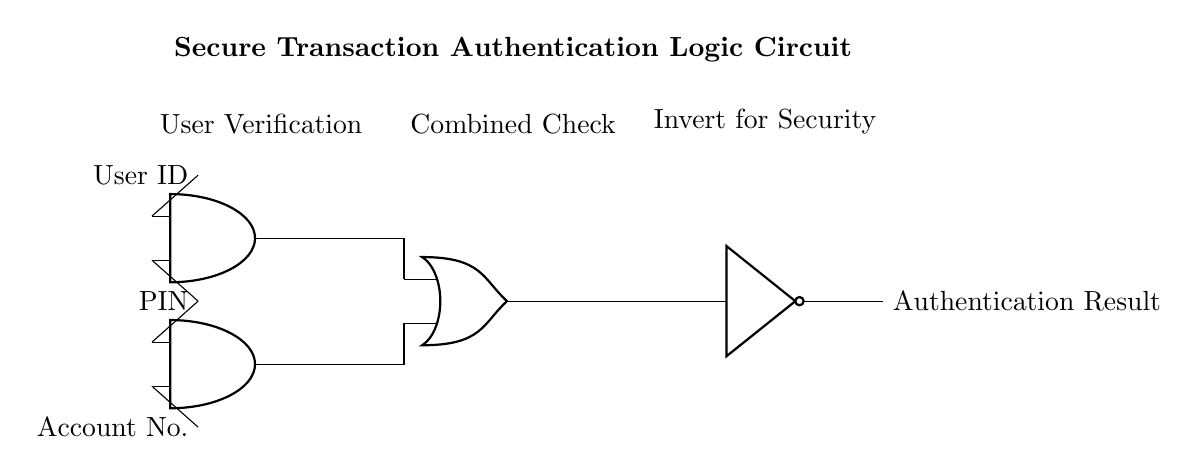What are the main components in this circuit? The circuit contains AND gates, an OR gate, and a NOT gate, which are the basic logic gates used for processing the authentication inputs.
Answer: AND gates, OR gate, NOT gate How many input signals are there in the circuit? There are three input signals: User ID, PIN, and Account Number. Each input contributes to the authentication logic.
Answer: Three What is the output of the circuit? The output is the "Authentication Result," which indicates whether the transaction is secure based on the inputs processed through the logic gates.
Answer: Authentication Result Where do the AND gates receive their inputs from? The first AND gate receives inputs from User ID and PIN, while the second AND gate receives inputs from the PIN and Account Number, allowing for multi-factor verification.
Answer: User ID and PIN; PIN and Account Number What does the NOT gate signify in this circuit? The NOT gate inverts the output from the OR gate, indicating that the final authentication result is dependent on the combination of conditions checked before it, enhancing security.
Answer: Inversion for security How are the outputs of the AND gates connected in this circuit? The outputs of both AND gates are connected to the inputs of the OR gate, meaning that either condition can lead to a positive output for further processing.
Answer: Connected to OR gate What role does the OR gate play in the authentication process? The OR gate combines the outputs from both AND gates, allowing the authentication to succeed if any of the conditions are met, which increases the accessibility of secure transactions.
Answer: Condition combination 